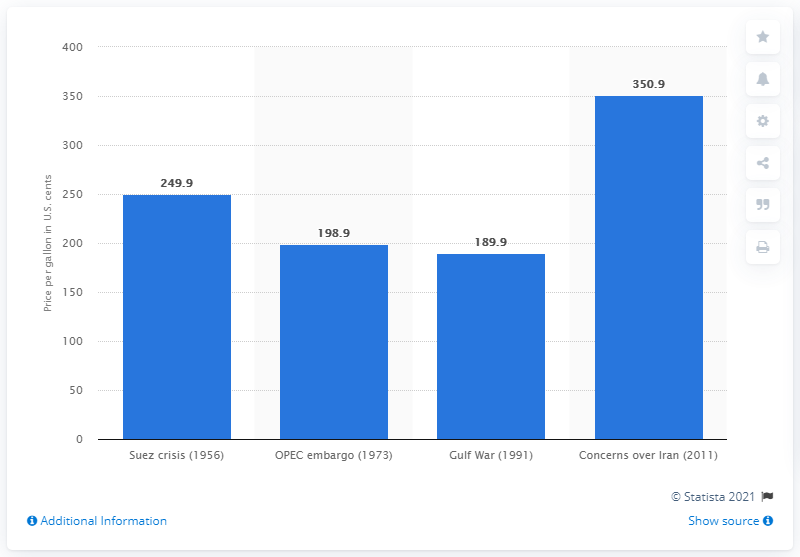Mention a couple of crucial points in this snapshot. In 1956, the average annual gasoline price in the United States was approximately 249.9 cents per gallon. 